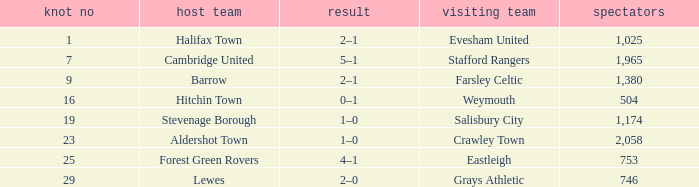Who was the away team in a tie no larger than 16 with forest green rovers at home? Eastleigh. 